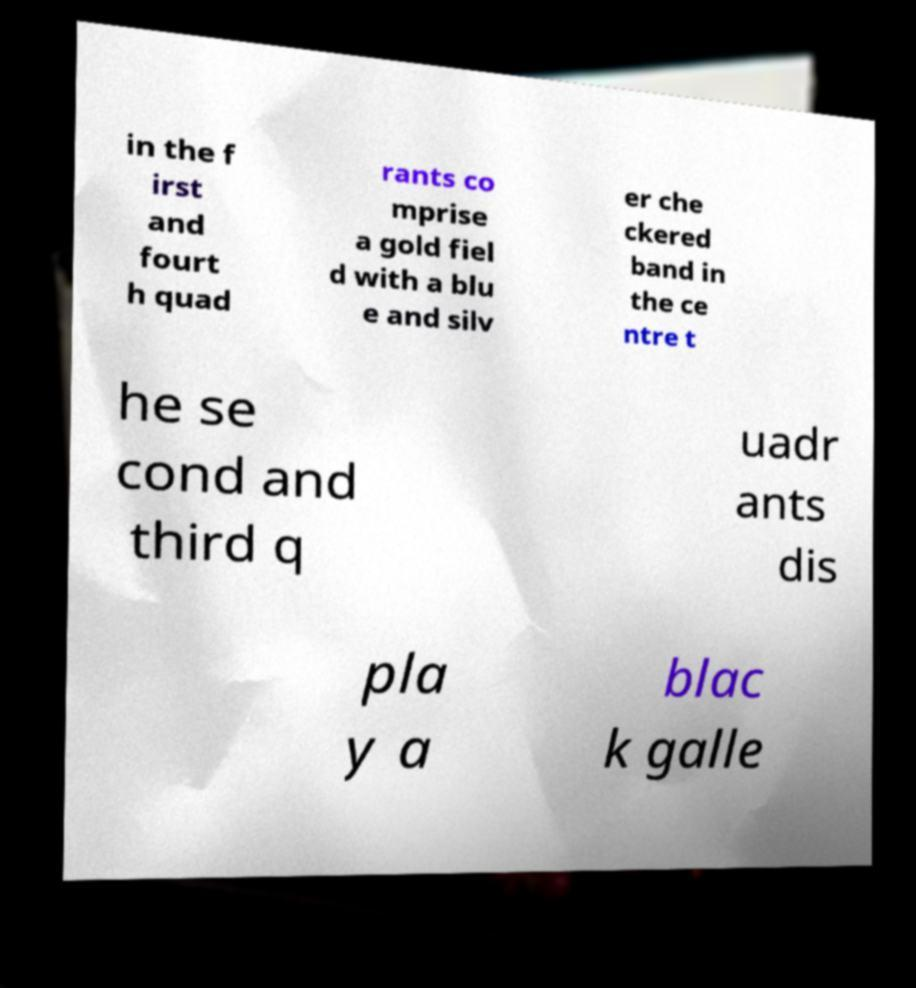I need the written content from this picture converted into text. Can you do that? in the f irst and fourt h quad rants co mprise a gold fiel d with a blu e and silv er che ckered band in the ce ntre t he se cond and third q uadr ants dis pla y a blac k galle 